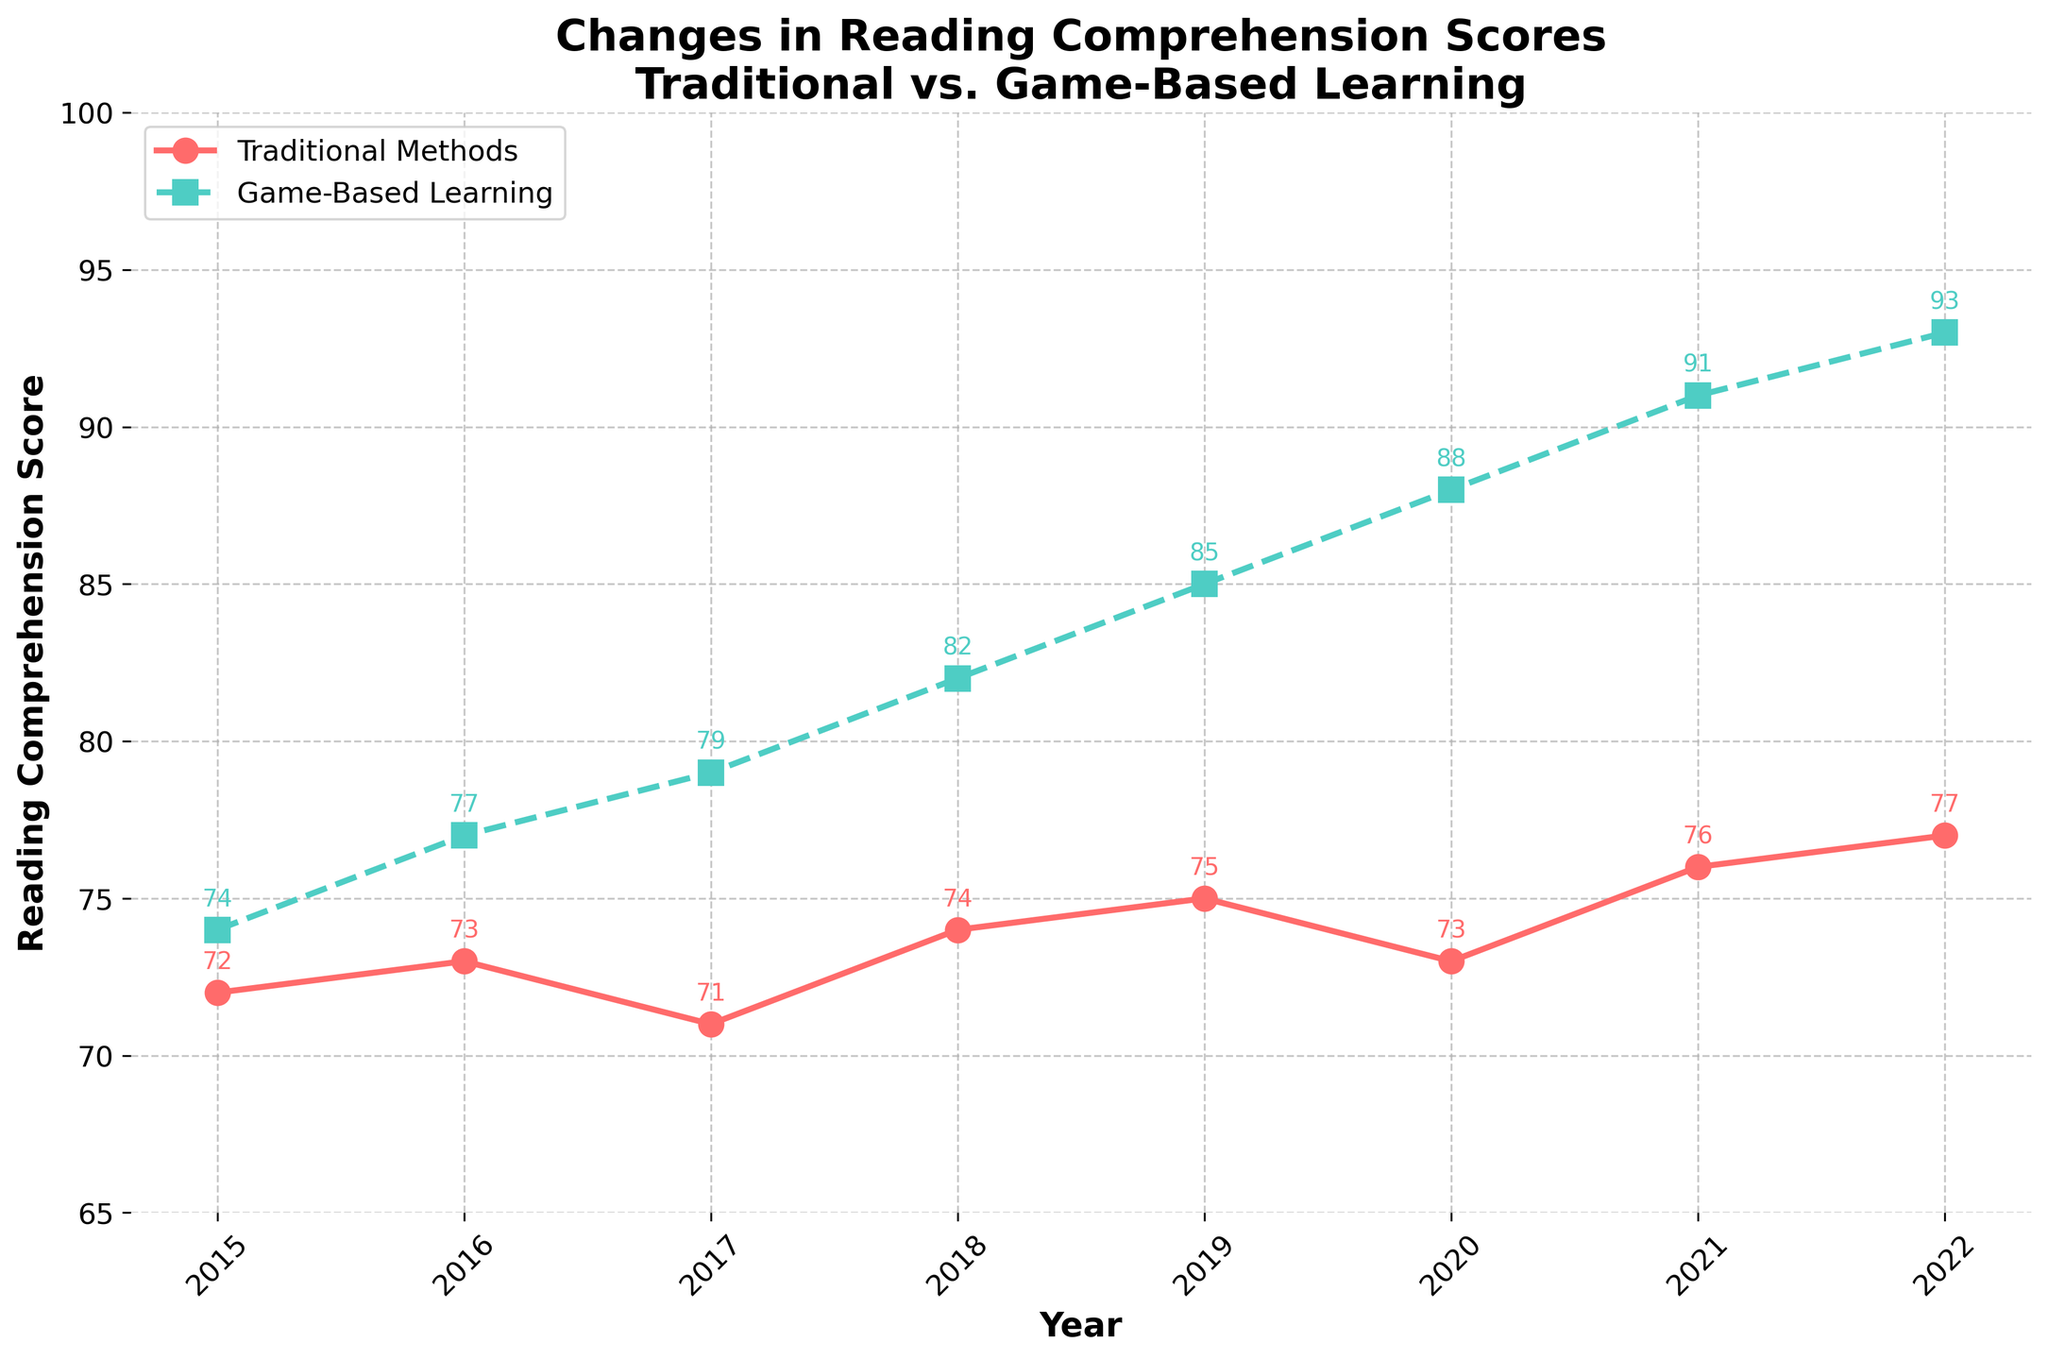Which year shows the highest reading comprehension score for game-based learning? The highest reading comprehension score for game-based learning can be identified by looking at the green line and finding the peak value. The peak value is in 2022 with a score of 93.
Answer: 2022 In which year did traditional methods and game-based learning have the smallest difference in reading comprehension scores? To find the smallest difference, subtract the traditional reading score from the game-based reading score for each year and compare these differences. The smallest difference appears in 2015 with a difference of 2 (74 - 72).
Answer: 2015 How much did the reading comprehension score improve for game-based learning from 2015 to 2022? Subtract the 2015 score from the 2022 score for game-based learning. The scores are 74 in 2015 and 93 in 2022. The difference is 93 - 74 = 19 points.
Answer: 19 points Which instructional method shows a more consistent trend in scores across the years? Examine the lines for both methods. The red line (traditional methods) shows minor fluctuations, while the green line (game-based learning) shows a steady and significant increase. Therefore, traditional methods are more consistent.
Answer: Traditional methods In what year do the traditional methods and game-based learning scores intersect or are closest to each other? The lines do not intersect, so check the smallest difference manually. The closest scores are in 2015 with 72 and 74.
Answer: 2015 What is the average reading comprehension score for traditional methods from 2015 to 2022? Sum the traditional method scores from 2015 to 2022 (72 + 73 + 71 + 74 + 75 + 73 + 76 + 77) and divide by the number of years (8). The total is 591, so the average is 591 / 8 = 73.875.
Answer: 73.875 Between 2019 and 2020, which method showed a decline in reading scores? Compare the scores for both methods between 2019 and 2020. For traditional, scores went from 75 to 73 (a decline). For game-based, scores increased from 85 to 88 (no decline).
Answer: Traditional methods In which year did game-based learning surpass 80 points for the first time? Look at the green line for the first instance of the score surpassing 80. This occurs in 2018 with a score of 82.
Answer: 2018 What is the difference in reading comprehension scores between traditional methods and game-based learning in 2022? The scores for 2022 are 77 for traditional methods and 93 for game-based learning. The difference is 93 - 77 = 16 points.
Answer: 16 points How many points higher is the game-based learning score compared to traditional methods in 2020? The scores for 2020 are 73 for traditional methods and 88 for game-based learning. The difference is 88 - 73 = 15 points.
Answer: 15 points 